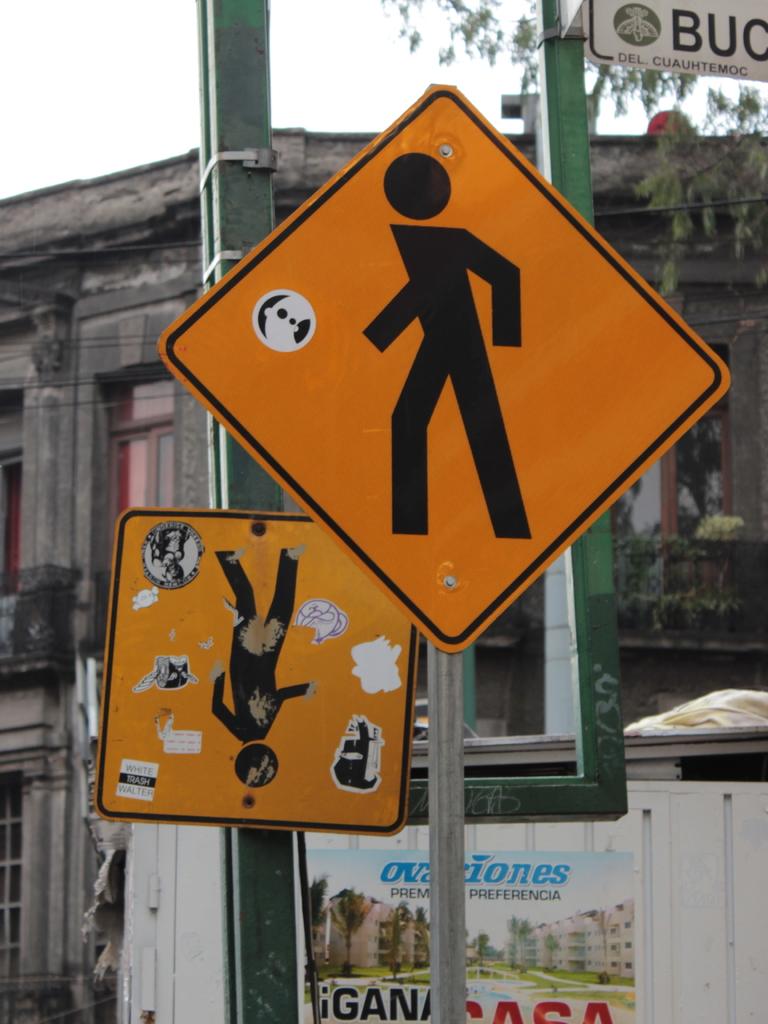What does it say behind the sign?
Ensure brevity in your answer.  Unanswerable. Who does it say is white trash?
Your answer should be compact. Walter. 